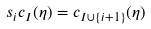<formula> <loc_0><loc_0><loc_500><loc_500>s _ { i } c _ { I } ( \eta ) = c _ { I \cup \{ i + 1 \} } ( \eta )</formula> 